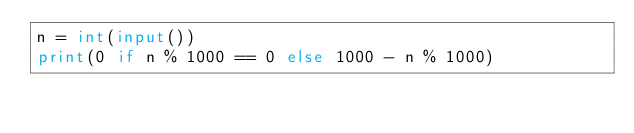<code> <loc_0><loc_0><loc_500><loc_500><_Python_>n = int(input())
print(0 if n % 1000 == 0 else 1000 - n % 1000)</code> 